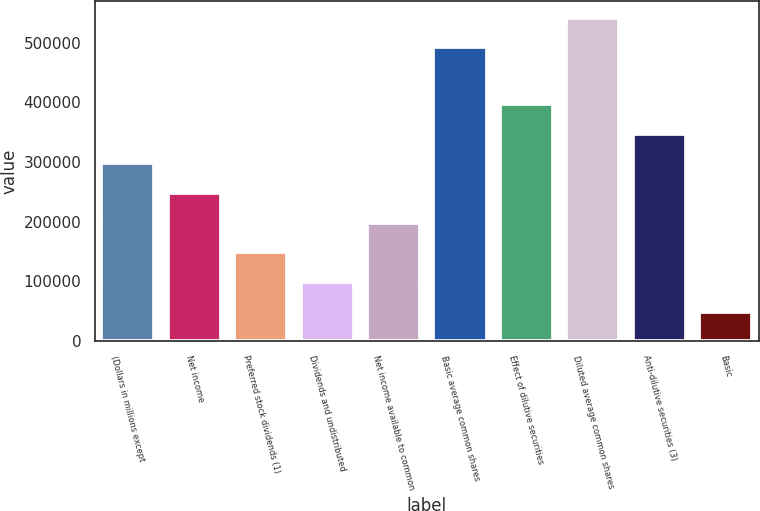Convert chart to OTSL. <chart><loc_0><loc_0><loc_500><loc_500><bar_chart><fcel>(Dollars in millions except<fcel>Net income<fcel>Preferred stock dividends (1)<fcel>Dividends and undistributed<fcel>Net income available to common<fcel>Basic average common shares<fcel>Effect of dilutive securities<fcel>Diluted average common shares<fcel>Anti-dilutive securities (3)<fcel>Basic<nl><fcel>297645<fcel>248038<fcel>148824<fcel>99217.4<fcel>198431<fcel>492598<fcel>396858<fcel>542205<fcel>347252<fcel>49610.6<nl></chart> 